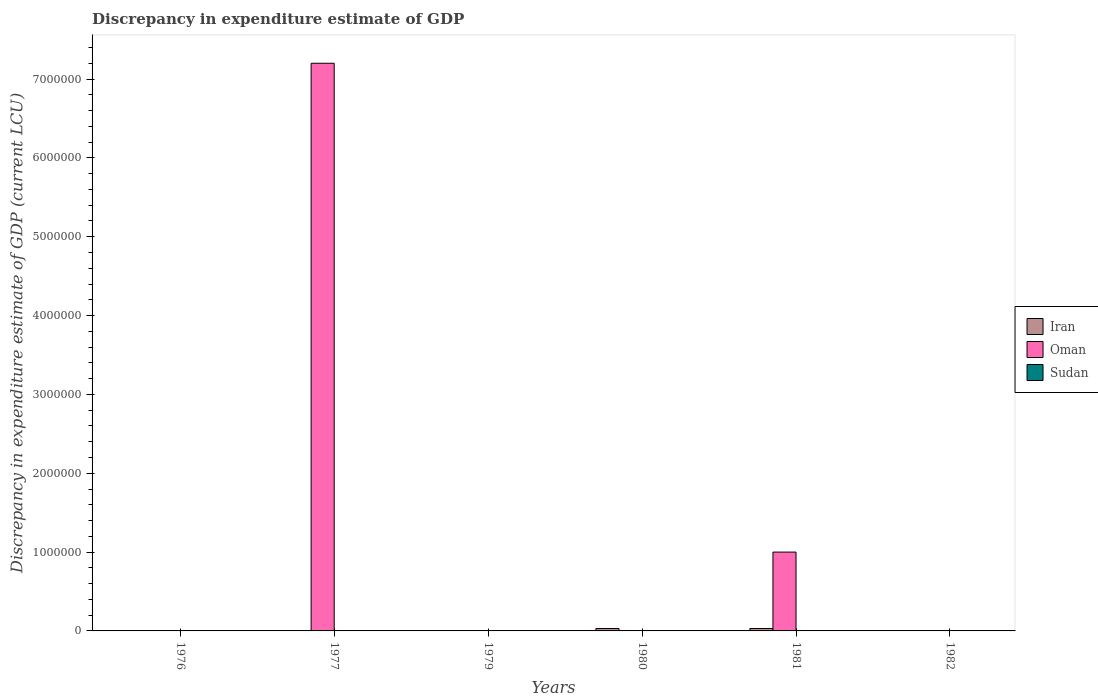How many different coloured bars are there?
Give a very brief answer. 2. Are the number of bars per tick equal to the number of legend labels?
Provide a succinct answer. No. Are the number of bars on each tick of the X-axis equal?
Keep it short and to the point. No. How many bars are there on the 6th tick from the left?
Your response must be concise. 1. What is the label of the 3rd group of bars from the left?
Offer a very short reply. 1979. What is the discrepancy in expenditure estimate of GDP in Oman in 1977?
Offer a very short reply. 7.20e+06. Across all years, what is the maximum discrepancy in expenditure estimate of GDP in Oman?
Provide a succinct answer. 7.20e+06. In which year was the discrepancy in expenditure estimate of GDP in Sudan maximum?
Your answer should be very brief. 1979. What is the total discrepancy in expenditure estimate of GDP in Iran in the graph?
Your answer should be very brief. 0. What is the difference between the discrepancy in expenditure estimate of GDP in Oman in 1977 and that in 1981?
Your response must be concise. 6.20e+06. What is the difference between the discrepancy in expenditure estimate of GDP in Oman in 1981 and the discrepancy in expenditure estimate of GDP in Sudan in 1979?
Give a very brief answer. 1.00e+06. What is the average discrepancy in expenditure estimate of GDP in Oman per year?
Provide a short and direct response. 1.37e+06. In how many years, is the discrepancy in expenditure estimate of GDP in Iran greater than 7200000 LCU?
Provide a short and direct response. 0. What is the difference between the highest and the second highest discrepancy in expenditure estimate of GDP in Oman?
Your answer should be compact. 6.20e+06. What is the difference between the highest and the lowest discrepancy in expenditure estimate of GDP in Sudan?
Offer a terse response. 100. How many years are there in the graph?
Offer a terse response. 6. What is the difference between two consecutive major ticks on the Y-axis?
Your answer should be very brief. 1.00e+06. Where does the legend appear in the graph?
Offer a terse response. Center right. What is the title of the graph?
Provide a short and direct response. Discrepancy in expenditure estimate of GDP. What is the label or title of the Y-axis?
Your answer should be compact. Discrepancy in expenditure estimate of GDP (current LCU). What is the Discrepancy in expenditure estimate of GDP (current LCU) of Oman in 1976?
Your response must be concise. 100. What is the Discrepancy in expenditure estimate of GDP (current LCU) in Oman in 1977?
Provide a short and direct response. 7.20e+06. What is the Discrepancy in expenditure estimate of GDP (current LCU) of Sudan in 1979?
Give a very brief answer. 100. What is the Discrepancy in expenditure estimate of GDP (current LCU) of Sudan in 1980?
Your response must be concise. 0. What is the Discrepancy in expenditure estimate of GDP (current LCU) in Iran in 1981?
Make the answer very short. 0. What is the Discrepancy in expenditure estimate of GDP (current LCU) of Oman in 1981?
Give a very brief answer. 1.00e+06. What is the Discrepancy in expenditure estimate of GDP (current LCU) of Sudan in 1981?
Offer a very short reply. 0. What is the Discrepancy in expenditure estimate of GDP (current LCU) of Sudan in 1982?
Ensure brevity in your answer.  0. Across all years, what is the maximum Discrepancy in expenditure estimate of GDP (current LCU) of Oman?
Make the answer very short. 7.20e+06. Across all years, what is the maximum Discrepancy in expenditure estimate of GDP (current LCU) of Sudan?
Give a very brief answer. 100. Across all years, what is the minimum Discrepancy in expenditure estimate of GDP (current LCU) of Sudan?
Provide a succinct answer. 0. What is the total Discrepancy in expenditure estimate of GDP (current LCU) in Iran in the graph?
Offer a terse response. 0. What is the total Discrepancy in expenditure estimate of GDP (current LCU) in Oman in the graph?
Your answer should be very brief. 8.20e+06. What is the difference between the Discrepancy in expenditure estimate of GDP (current LCU) of Oman in 1976 and that in 1977?
Your response must be concise. -7.20e+06. What is the difference between the Discrepancy in expenditure estimate of GDP (current LCU) in Oman in 1976 and that in 1979?
Give a very brief answer. -100. What is the difference between the Discrepancy in expenditure estimate of GDP (current LCU) of Oman in 1976 and that in 1981?
Provide a succinct answer. -1.00e+06. What is the difference between the Discrepancy in expenditure estimate of GDP (current LCU) in Oman in 1976 and that in 1982?
Ensure brevity in your answer.  -0. What is the difference between the Discrepancy in expenditure estimate of GDP (current LCU) in Oman in 1977 and that in 1979?
Your response must be concise. 7.20e+06. What is the difference between the Discrepancy in expenditure estimate of GDP (current LCU) in Oman in 1977 and that in 1981?
Your answer should be very brief. 6.20e+06. What is the difference between the Discrepancy in expenditure estimate of GDP (current LCU) of Oman in 1977 and that in 1982?
Offer a very short reply. 7.20e+06. What is the difference between the Discrepancy in expenditure estimate of GDP (current LCU) of Oman in 1979 and that in 1981?
Ensure brevity in your answer.  -1.00e+06. What is the difference between the Discrepancy in expenditure estimate of GDP (current LCU) of Oman in 1981 and that in 1982?
Your answer should be compact. 1.00e+06. What is the difference between the Discrepancy in expenditure estimate of GDP (current LCU) of Oman in 1977 and the Discrepancy in expenditure estimate of GDP (current LCU) of Sudan in 1979?
Provide a succinct answer. 7.20e+06. What is the average Discrepancy in expenditure estimate of GDP (current LCU) of Iran per year?
Your response must be concise. 0. What is the average Discrepancy in expenditure estimate of GDP (current LCU) of Oman per year?
Your answer should be compact. 1.37e+06. What is the average Discrepancy in expenditure estimate of GDP (current LCU) of Sudan per year?
Provide a short and direct response. 16.67. What is the ratio of the Discrepancy in expenditure estimate of GDP (current LCU) of Oman in 1976 to that in 1982?
Your answer should be very brief. 1. What is the ratio of the Discrepancy in expenditure estimate of GDP (current LCU) of Oman in 1977 to that in 1979?
Offer a terse response. 3.60e+04. What is the ratio of the Discrepancy in expenditure estimate of GDP (current LCU) in Oman in 1977 to that in 1981?
Keep it short and to the point. 7.2. What is the ratio of the Discrepancy in expenditure estimate of GDP (current LCU) in Oman in 1977 to that in 1982?
Provide a short and direct response. 7.20e+04. What is the ratio of the Discrepancy in expenditure estimate of GDP (current LCU) of Oman in 1979 to that in 1981?
Provide a short and direct response. 0. What is the ratio of the Discrepancy in expenditure estimate of GDP (current LCU) of Oman in 1979 to that in 1982?
Keep it short and to the point. 2. What is the ratio of the Discrepancy in expenditure estimate of GDP (current LCU) in Oman in 1981 to that in 1982?
Offer a terse response. 10000. What is the difference between the highest and the second highest Discrepancy in expenditure estimate of GDP (current LCU) of Oman?
Your answer should be very brief. 6.20e+06. What is the difference between the highest and the lowest Discrepancy in expenditure estimate of GDP (current LCU) in Oman?
Offer a terse response. 7.20e+06. What is the difference between the highest and the lowest Discrepancy in expenditure estimate of GDP (current LCU) in Sudan?
Offer a terse response. 100. 